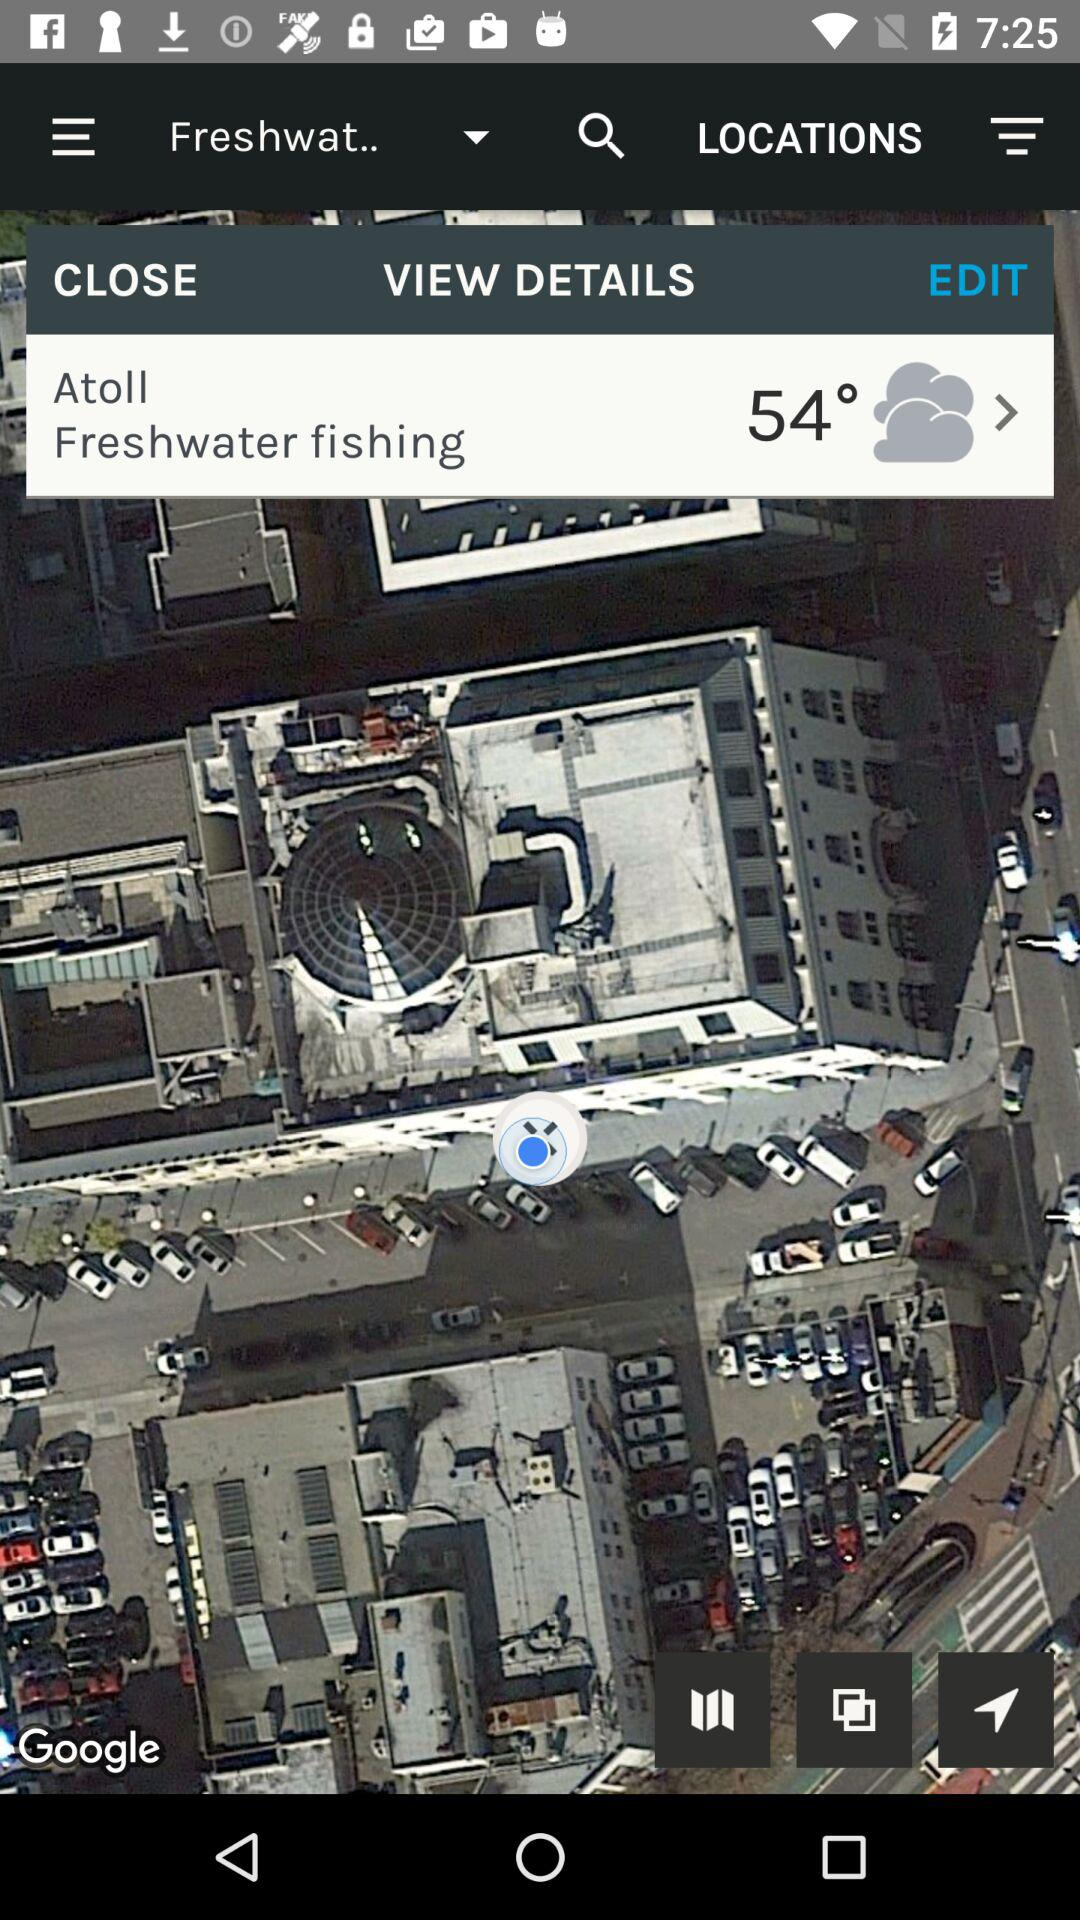How many degrees is the temperature?
Answer the question using a single word or phrase. 54° 